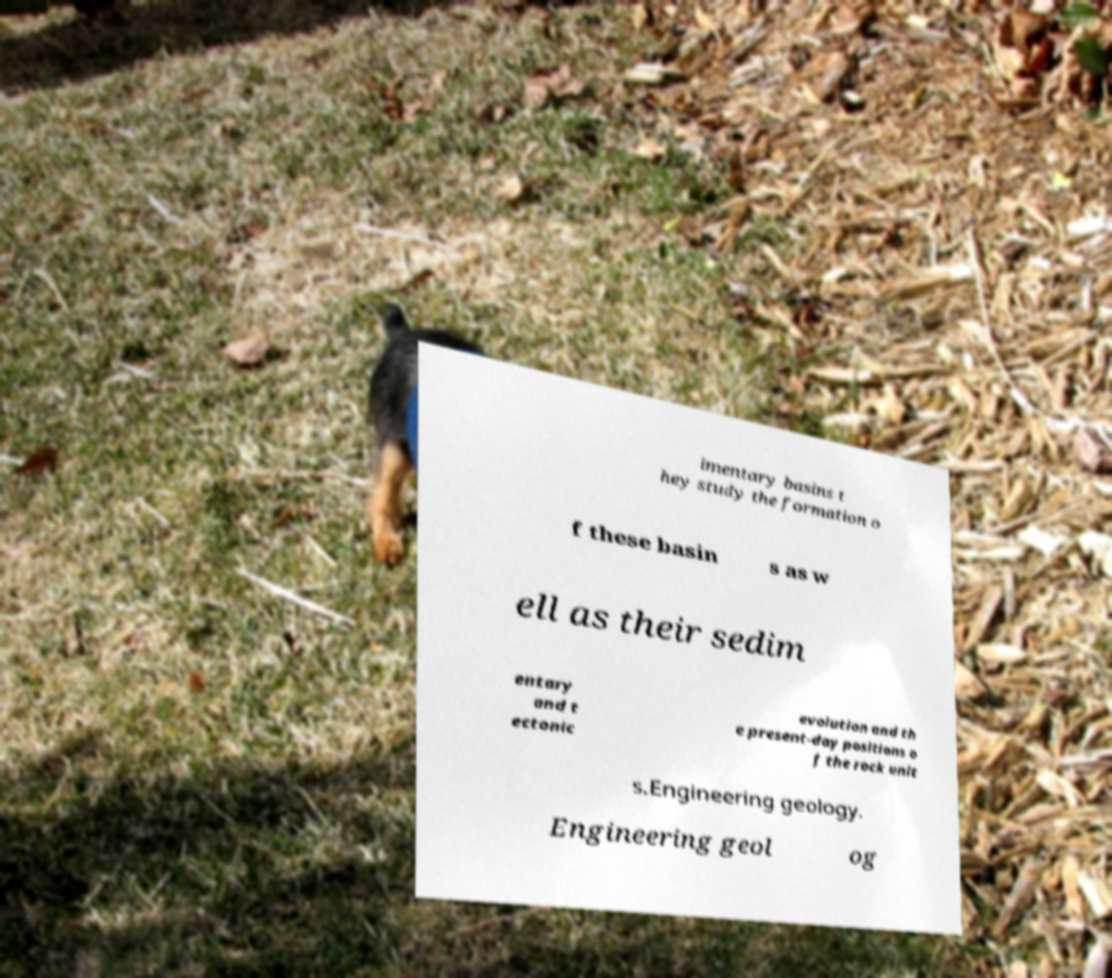Could you extract and type out the text from this image? imentary basins t hey study the formation o f these basin s as w ell as their sedim entary and t ectonic evolution and th e present-day positions o f the rock unit s.Engineering geology. Engineering geol og 